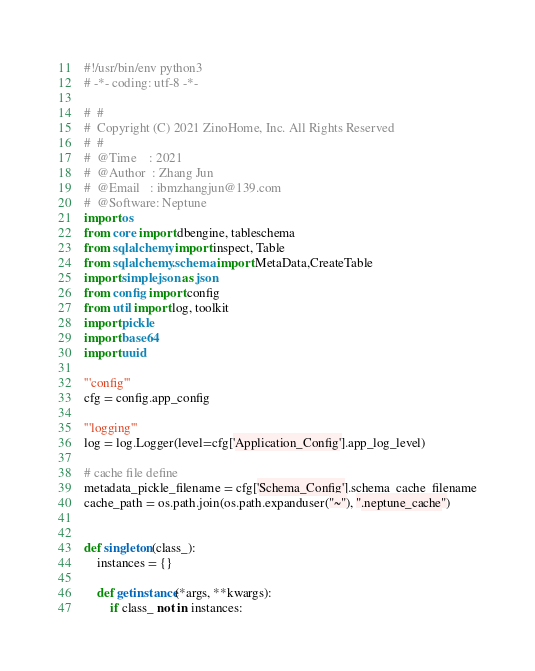<code> <loc_0><loc_0><loc_500><loc_500><_Python_>#!/usr/bin/env python3
# -*- coding: utf-8 -*-

#  #
#  Copyright (C) 2021 ZinoHome, Inc. All Rights Reserved
#  #
#  @Time    : 2021
#  @Author  : Zhang Jun
#  @Email   : ibmzhangjun@139.com
#  @Software: Neptune
import os
from core import dbengine, tableschema
from sqlalchemy import inspect, Table
from sqlalchemy.schema import MetaData,CreateTable
import simplejson as json
from config import config
from util import log, toolkit
import pickle
import base64
import uuid

'''config'''
cfg = config.app_config

'''logging'''
log = log.Logger(level=cfg['Application_Config'].app_log_level)

# cache file define
metadata_pickle_filename = cfg['Schema_Config'].schema_cache_filename
cache_path = os.path.join(os.path.expanduser("~"), ".neptune_cache")


def singleton(class_):
    instances = {}

    def getinstance(*args, **kwargs):
        if class_ not in instances:</code> 